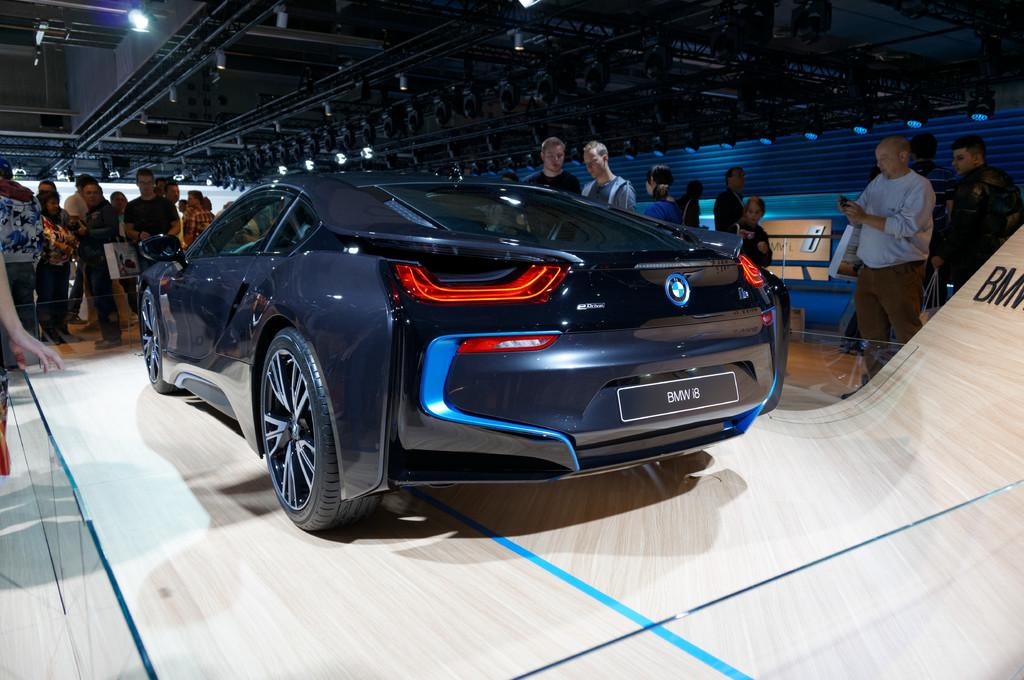How many people are in the image? There are people in the image, but the exact number is not specified. What type of vehicle is in the image? There is a vehicle in the image, but the specific type is not mentioned. What can be seen in the image that emits light? There are lights in the image. What is the purpose of the boards in the image? Something is written on the boards, but the content or purpose is not specified. What objects are under the shed? There are objects under the shed, but their nature is not described. What are some people holding in the image? Some people are holding objects, but their nature is not described. Where is the stage located in the image? There is no stage present in the image. What does the mom say to the child in the image? There is no mention of a mom or a child in the image. 